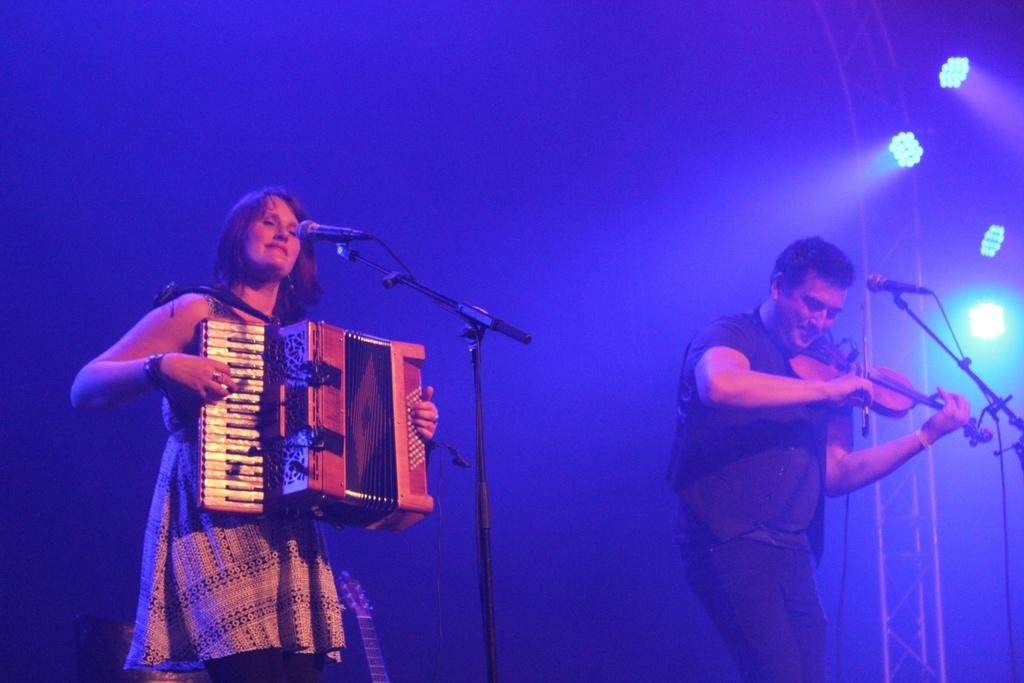What is the man in the image doing? The man is playing a violin in the image. What is the lady in the image doing? The lady is playing an accordion in the image. What objects are present in the image to amplify sound? There are microphones placed on stands in the image. What can be seen in the image to provide illumination? There are lights visible in the image. What color is the pig in the image? There is no pig present in the image. What type of laborer can be seen working in the image? There are no laborers present in the image; it features musicians playing instruments. 